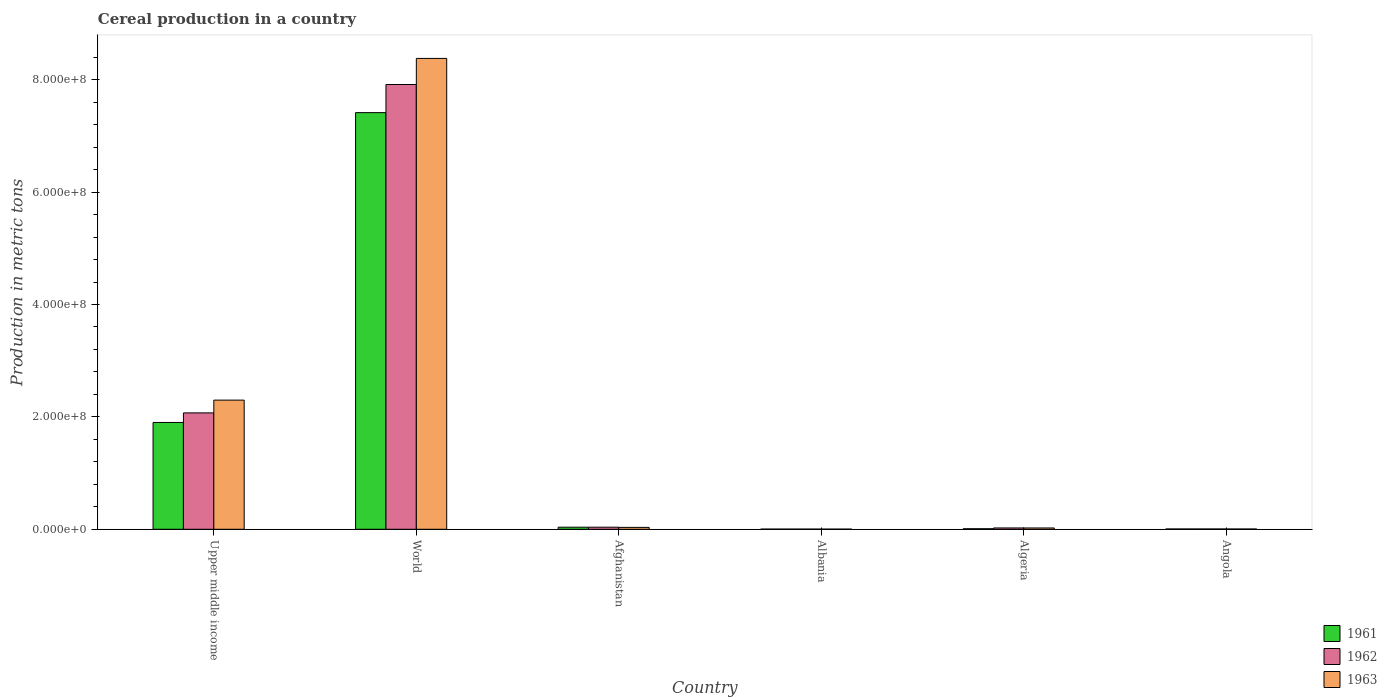Are the number of bars per tick equal to the number of legend labels?
Your answer should be very brief. Yes. Are the number of bars on each tick of the X-axis equal?
Offer a very short reply. Yes. What is the label of the 4th group of bars from the left?
Offer a very short reply. Albania. In how many cases, is the number of bars for a given country not equal to the number of legend labels?
Make the answer very short. 0. What is the total cereal production in 1961 in Algeria?
Keep it short and to the point. 9.38e+05. Across all countries, what is the maximum total cereal production in 1962?
Give a very brief answer. 7.92e+08. Across all countries, what is the minimum total cereal production in 1961?
Your answer should be very brief. 2.94e+05. In which country was the total cereal production in 1963 maximum?
Provide a succinct answer. World. In which country was the total cereal production in 1963 minimum?
Offer a terse response. Albania. What is the total total cereal production in 1962 in the graph?
Your response must be concise. 1.01e+09. What is the difference between the total cereal production in 1961 in Algeria and that in World?
Provide a short and direct response. -7.41e+08. What is the difference between the total cereal production in 1962 in Angola and the total cereal production in 1963 in Albania?
Your answer should be very brief. 2.50e+05. What is the average total cereal production in 1961 per country?
Your answer should be compact. 1.56e+08. What is the difference between the total cereal production of/in 1963 and total cereal production of/in 1962 in Angola?
Offer a very short reply. -2.80e+04. What is the ratio of the total cereal production in 1961 in Albania to that in World?
Ensure brevity in your answer.  0. What is the difference between the highest and the second highest total cereal production in 1962?
Offer a terse response. -2.03e+08. What is the difference between the highest and the lowest total cereal production in 1962?
Make the answer very short. 7.91e+08. What does the 2nd bar from the left in Algeria represents?
Offer a terse response. 1962. What does the 3rd bar from the right in Upper middle income represents?
Provide a short and direct response. 1961. Is it the case that in every country, the sum of the total cereal production in 1962 and total cereal production in 1963 is greater than the total cereal production in 1961?
Make the answer very short. Yes. How many bars are there?
Your answer should be very brief. 18. How many countries are there in the graph?
Your answer should be compact. 6. What is the difference between two consecutive major ticks on the Y-axis?
Offer a very short reply. 2.00e+08. Are the values on the major ticks of Y-axis written in scientific E-notation?
Your answer should be very brief. Yes. Does the graph contain grids?
Your answer should be compact. No. Where does the legend appear in the graph?
Ensure brevity in your answer.  Bottom right. What is the title of the graph?
Your answer should be very brief. Cereal production in a country. Does "1980" appear as one of the legend labels in the graph?
Offer a very short reply. No. What is the label or title of the Y-axis?
Your answer should be compact. Production in metric tons. What is the Production in metric tons in 1961 in Upper middle income?
Ensure brevity in your answer.  1.90e+08. What is the Production in metric tons of 1962 in Upper middle income?
Offer a very short reply. 2.07e+08. What is the Production in metric tons in 1963 in Upper middle income?
Your response must be concise. 2.30e+08. What is the Production in metric tons of 1961 in World?
Ensure brevity in your answer.  7.41e+08. What is the Production in metric tons in 1962 in World?
Your answer should be very brief. 7.92e+08. What is the Production in metric tons of 1963 in World?
Provide a short and direct response. 8.38e+08. What is the Production in metric tons of 1961 in Afghanistan?
Keep it short and to the point. 3.70e+06. What is the Production in metric tons of 1962 in Afghanistan?
Provide a short and direct response. 3.70e+06. What is the Production in metric tons in 1963 in Afghanistan?
Provide a succinct answer. 3.38e+06. What is the Production in metric tons of 1961 in Albania?
Your answer should be very brief. 2.94e+05. What is the Production in metric tons of 1962 in Albania?
Your response must be concise. 3.14e+05. What is the Production in metric tons in 1963 in Albania?
Provide a succinct answer. 2.93e+05. What is the Production in metric tons in 1961 in Algeria?
Keep it short and to the point. 9.38e+05. What is the Production in metric tons of 1962 in Algeria?
Keep it short and to the point. 2.37e+06. What is the Production in metric tons of 1963 in Algeria?
Provide a short and direct response. 2.32e+06. What is the Production in metric tons of 1961 in Angola?
Offer a very short reply. 5.44e+05. What is the Production in metric tons in 1962 in Angola?
Ensure brevity in your answer.  5.43e+05. What is the Production in metric tons of 1963 in Angola?
Keep it short and to the point. 5.15e+05. Across all countries, what is the maximum Production in metric tons of 1961?
Your response must be concise. 7.41e+08. Across all countries, what is the maximum Production in metric tons of 1962?
Provide a short and direct response. 7.92e+08. Across all countries, what is the maximum Production in metric tons of 1963?
Give a very brief answer. 8.38e+08. Across all countries, what is the minimum Production in metric tons of 1961?
Provide a short and direct response. 2.94e+05. Across all countries, what is the minimum Production in metric tons of 1962?
Provide a short and direct response. 3.14e+05. Across all countries, what is the minimum Production in metric tons of 1963?
Offer a very short reply. 2.93e+05. What is the total Production in metric tons of 1961 in the graph?
Ensure brevity in your answer.  9.37e+08. What is the total Production in metric tons of 1962 in the graph?
Give a very brief answer. 1.01e+09. What is the total Production in metric tons of 1963 in the graph?
Provide a short and direct response. 1.07e+09. What is the difference between the Production in metric tons in 1961 in Upper middle income and that in World?
Make the answer very short. -5.51e+08. What is the difference between the Production in metric tons in 1962 in Upper middle income and that in World?
Give a very brief answer. -5.84e+08. What is the difference between the Production in metric tons in 1963 in Upper middle income and that in World?
Provide a succinct answer. -6.08e+08. What is the difference between the Production in metric tons of 1961 in Upper middle income and that in Afghanistan?
Your response must be concise. 1.86e+08. What is the difference between the Production in metric tons in 1962 in Upper middle income and that in Afghanistan?
Keep it short and to the point. 2.03e+08. What is the difference between the Production in metric tons in 1963 in Upper middle income and that in Afghanistan?
Provide a succinct answer. 2.26e+08. What is the difference between the Production in metric tons in 1961 in Upper middle income and that in Albania?
Make the answer very short. 1.90e+08. What is the difference between the Production in metric tons in 1962 in Upper middle income and that in Albania?
Make the answer very short. 2.07e+08. What is the difference between the Production in metric tons in 1963 in Upper middle income and that in Albania?
Make the answer very short. 2.30e+08. What is the difference between the Production in metric tons of 1961 in Upper middle income and that in Algeria?
Provide a succinct answer. 1.89e+08. What is the difference between the Production in metric tons of 1962 in Upper middle income and that in Algeria?
Offer a very short reply. 2.05e+08. What is the difference between the Production in metric tons of 1963 in Upper middle income and that in Algeria?
Ensure brevity in your answer.  2.28e+08. What is the difference between the Production in metric tons in 1961 in Upper middle income and that in Angola?
Your answer should be very brief. 1.90e+08. What is the difference between the Production in metric tons of 1962 in Upper middle income and that in Angola?
Provide a succinct answer. 2.07e+08. What is the difference between the Production in metric tons of 1963 in Upper middle income and that in Angola?
Make the answer very short. 2.29e+08. What is the difference between the Production in metric tons of 1961 in World and that in Afghanistan?
Offer a very short reply. 7.38e+08. What is the difference between the Production in metric tons in 1962 in World and that in Afghanistan?
Provide a succinct answer. 7.88e+08. What is the difference between the Production in metric tons in 1963 in World and that in Afghanistan?
Provide a succinct answer. 8.35e+08. What is the difference between the Production in metric tons in 1961 in World and that in Albania?
Give a very brief answer. 7.41e+08. What is the difference between the Production in metric tons of 1962 in World and that in Albania?
Make the answer very short. 7.91e+08. What is the difference between the Production in metric tons in 1963 in World and that in Albania?
Offer a very short reply. 8.38e+08. What is the difference between the Production in metric tons in 1961 in World and that in Algeria?
Offer a terse response. 7.41e+08. What is the difference between the Production in metric tons of 1962 in World and that in Algeria?
Provide a short and direct response. 7.89e+08. What is the difference between the Production in metric tons in 1963 in World and that in Algeria?
Your answer should be very brief. 8.36e+08. What is the difference between the Production in metric tons of 1961 in World and that in Angola?
Provide a short and direct response. 7.41e+08. What is the difference between the Production in metric tons of 1962 in World and that in Angola?
Your answer should be very brief. 7.91e+08. What is the difference between the Production in metric tons of 1963 in World and that in Angola?
Give a very brief answer. 8.37e+08. What is the difference between the Production in metric tons in 1961 in Afghanistan and that in Albania?
Keep it short and to the point. 3.40e+06. What is the difference between the Production in metric tons in 1962 in Afghanistan and that in Albania?
Ensure brevity in your answer.  3.38e+06. What is the difference between the Production in metric tons in 1963 in Afghanistan and that in Albania?
Your answer should be very brief. 3.08e+06. What is the difference between the Production in metric tons of 1961 in Afghanistan and that in Algeria?
Provide a succinct answer. 2.76e+06. What is the difference between the Production in metric tons in 1962 in Afghanistan and that in Algeria?
Your answer should be compact. 1.33e+06. What is the difference between the Production in metric tons in 1963 in Afghanistan and that in Algeria?
Give a very brief answer. 1.05e+06. What is the difference between the Production in metric tons of 1961 in Afghanistan and that in Angola?
Your answer should be compact. 3.15e+06. What is the difference between the Production in metric tons in 1962 in Afghanistan and that in Angola?
Keep it short and to the point. 3.15e+06. What is the difference between the Production in metric tons of 1963 in Afghanistan and that in Angola?
Provide a succinct answer. 2.86e+06. What is the difference between the Production in metric tons of 1961 in Albania and that in Algeria?
Make the answer very short. -6.44e+05. What is the difference between the Production in metric tons of 1962 in Albania and that in Algeria?
Your answer should be very brief. -2.06e+06. What is the difference between the Production in metric tons of 1963 in Albania and that in Algeria?
Your answer should be compact. -2.03e+06. What is the difference between the Production in metric tons in 1961 in Albania and that in Angola?
Provide a short and direct response. -2.50e+05. What is the difference between the Production in metric tons of 1962 in Albania and that in Angola?
Your answer should be compact. -2.29e+05. What is the difference between the Production in metric tons in 1963 in Albania and that in Angola?
Provide a succinct answer. -2.22e+05. What is the difference between the Production in metric tons in 1961 in Algeria and that in Angola?
Keep it short and to the point. 3.94e+05. What is the difference between the Production in metric tons in 1962 in Algeria and that in Angola?
Ensure brevity in your answer.  1.83e+06. What is the difference between the Production in metric tons in 1963 in Algeria and that in Angola?
Your response must be concise. 1.81e+06. What is the difference between the Production in metric tons of 1961 in Upper middle income and the Production in metric tons of 1962 in World?
Your answer should be compact. -6.01e+08. What is the difference between the Production in metric tons in 1961 in Upper middle income and the Production in metric tons in 1963 in World?
Your answer should be compact. -6.48e+08. What is the difference between the Production in metric tons in 1962 in Upper middle income and the Production in metric tons in 1963 in World?
Provide a short and direct response. -6.31e+08. What is the difference between the Production in metric tons of 1961 in Upper middle income and the Production in metric tons of 1962 in Afghanistan?
Ensure brevity in your answer.  1.86e+08. What is the difference between the Production in metric tons of 1961 in Upper middle income and the Production in metric tons of 1963 in Afghanistan?
Ensure brevity in your answer.  1.87e+08. What is the difference between the Production in metric tons of 1962 in Upper middle income and the Production in metric tons of 1963 in Afghanistan?
Make the answer very short. 2.04e+08. What is the difference between the Production in metric tons of 1961 in Upper middle income and the Production in metric tons of 1962 in Albania?
Make the answer very short. 1.90e+08. What is the difference between the Production in metric tons of 1961 in Upper middle income and the Production in metric tons of 1963 in Albania?
Give a very brief answer. 1.90e+08. What is the difference between the Production in metric tons in 1962 in Upper middle income and the Production in metric tons in 1963 in Albania?
Your response must be concise. 2.07e+08. What is the difference between the Production in metric tons of 1961 in Upper middle income and the Production in metric tons of 1962 in Algeria?
Provide a succinct answer. 1.88e+08. What is the difference between the Production in metric tons of 1961 in Upper middle income and the Production in metric tons of 1963 in Algeria?
Keep it short and to the point. 1.88e+08. What is the difference between the Production in metric tons of 1962 in Upper middle income and the Production in metric tons of 1963 in Algeria?
Ensure brevity in your answer.  2.05e+08. What is the difference between the Production in metric tons of 1961 in Upper middle income and the Production in metric tons of 1962 in Angola?
Ensure brevity in your answer.  1.90e+08. What is the difference between the Production in metric tons in 1961 in Upper middle income and the Production in metric tons in 1963 in Angola?
Ensure brevity in your answer.  1.90e+08. What is the difference between the Production in metric tons in 1962 in Upper middle income and the Production in metric tons in 1963 in Angola?
Your answer should be very brief. 2.07e+08. What is the difference between the Production in metric tons of 1961 in World and the Production in metric tons of 1962 in Afghanistan?
Provide a short and direct response. 7.38e+08. What is the difference between the Production in metric tons in 1961 in World and the Production in metric tons in 1963 in Afghanistan?
Your answer should be compact. 7.38e+08. What is the difference between the Production in metric tons of 1962 in World and the Production in metric tons of 1963 in Afghanistan?
Give a very brief answer. 7.88e+08. What is the difference between the Production in metric tons in 1961 in World and the Production in metric tons in 1962 in Albania?
Provide a succinct answer. 7.41e+08. What is the difference between the Production in metric tons of 1961 in World and the Production in metric tons of 1963 in Albania?
Your answer should be very brief. 7.41e+08. What is the difference between the Production in metric tons of 1962 in World and the Production in metric tons of 1963 in Albania?
Give a very brief answer. 7.91e+08. What is the difference between the Production in metric tons in 1961 in World and the Production in metric tons in 1962 in Algeria?
Ensure brevity in your answer.  7.39e+08. What is the difference between the Production in metric tons in 1961 in World and the Production in metric tons in 1963 in Algeria?
Provide a succinct answer. 7.39e+08. What is the difference between the Production in metric tons of 1962 in World and the Production in metric tons of 1963 in Algeria?
Make the answer very short. 7.89e+08. What is the difference between the Production in metric tons of 1961 in World and the Production in metric tons of 1962 in Angola?
Your answer should be compact. 7.41e+08. What is the difference between the Production in metric tons of 1961 in World and the Production in metric tons of 1963 in Angola?
Provide a succinct answer. 7.41e+08. What is the difference between the Production in metric tons in 1962 in World and the Production in metric tons in 1963 in Angola?
Your answer should be compact. 7.91e+08. What is the difference between the Production in metric tons of 1961 in Afghanistan and the Production in metric tons of 1962 in Albania?
Your response must be concise. 3.38e+06. What is the difference between the Production in metric tons in 1961 in Afghanistan and the Production in metric tons in 1963 in Albania?
Your response must be concise. 3.40e+06. What is the difference between the Production in metric tons in 1962 in Afghanistan and the Production in metric tons in 1963 in Albania?
Your answer should be very brief. 3.40e+06. What is the difference between the Production in metric tons of 1961 in Afghanistan and the Production in metric tons of 1962 in Algeria?
Your answer should be compact. 1.33e+06. What is the difference between the Production in metric tons in 1961 in Afghanistan and the Production in metric tons in 1963 in Algeria?
Your answer should be very brief. 1.37e+06. What is the difference between the Production in metric tons in 1962 in Afghanistan and the Production in metric tons in 1963 in Algeria?
Provide a succinct answer. 1.37e+06. What is the difference between the Production in metric tons in 1961 in Afghanistan and the Production in metric tons in 1962 in Angola?
Keep it short and to the point. 3.15e+06. What is the difference between the Production in metric tons of 1961 in Afghanistan and the Production in metric tons of 1963 in Angola?
Make the answer very short. 3.18e+06. What is the difference between the Production in metric tons of 1962 in Afghanistan and the Production in metric tons of 1963 in Angola?
Keep it short and to the point. 3.18e+06. What is the difference between the Production in metric tons in 1961 in Albania and the Production in metric tons in 1962 in Algeria?
Make the answer very short. -2.08e+06. What is the difference between the Production in metric tons of 1961 in Albania and the Production in metric tons of 1963 in Algeria?
Keep it short and to the point. -2.03e+06. What is the difference between the Production in metric tons in 1962 in Albania and the Production in metric tons in 1963 in Algeria?
Offer a terse response. -2.01e+06. What is the difference between the Production in metric tons of 1961 in Albania and the Production in metric tons of 1962 in Angola?
Ensure brevity in your answer.  -2.49e+05. What is the difference between the Production in metric tons in 1961 in Albania and the Production in metric tons in 1963 in Angola?
Make the answer very short. -2.21e+05. What is the difference between the Production in metric tons in 1962 in Albania and the Production in metric tons in 1963 in Angola?
Provide a succinct answer. -2.01e+05. What is the difference between the Production in metric tons of 1961 in Algeria and the Production in metric tons of 1962 in Angola?
Offer a terse response. 3.95e+05. What is the difference between the Production in metric tons of 1961 in Algeria and the Production in metric tons of 1963 in Angola?
Give a very brief answer. 4.23e+05. What is the difference between the Production in metric tons in 1962 in Algeria and the Production in metric tons in 1963 in Angola?
Offer a very short reply. 1.85e+06. What is the average Production in metric tons in 1961 per country?
Offer a terse response. 1.56e+08. What is the average Production in metric tons in 1962 per country?
Ensure brevity in your answer.  1.68e+08. What is the average Production in metric tons of 1963 per country?
Your answer should be compact. 1.79e+08. What is the difference between the Production in metric tons of 1961 and Production in metric tons of 1962 in Upper middle income?
Provide a short and direct response. -1.70e+07. What is the difference between the Production in metric tons in 1961 and Production in metric tons in 1963 in Upper middle income?
Offer a terse response. -3.98e+07. What is the difference between the Production in metric tons of 1962 and Production in metric tons of 1963 in Upper middle income?
Provide a short and direct response. -2.27e+07. What is the difference between the Production in metric tons in 1961 and Production in metric tons in 1962 in World?
Your answer should be compact. -5.00e+07. What is the difference between the Production in metric tons of 1961 and Production in metric tons of 1963 in World?
Give a very brief answer. -9.65e+07. What is the difference between the Production in metric tons in 1962 and Production in metric tons in 1963 in World?
Ensure brevity in your answer.  -4.64e+07. What is the difference between the Production in metric tons in 1961 and Production in metric tons in 1962 in Afghanistan?
Your answer should be compact. -1000. What is the difference between the Production in metric tons of 1961 and Production in metric tons of 1963 in Afghanistan?
Offer a very short reply. 3.17e+05. What is the difference between the Production in metric tons in 1962 and Production in metric tons in 1963 in Afghanistan?
Your answer should be compact. 3.18e+05. What is the difference between the Production in metric tons in 1961 and Production in metric tons in 1962 in Albania?
Make the answer very short. -1.96e+04. What is the difference between the Production in metric tons in 1961 and Production in metric tons in 1963 in Albania?
Make the answer very short. 483. What is the difference between the Production in metric tons of 1962 and Production in metric tons of 1963 in Albania?
Give a very brief answer. 2.01e+04. What is the difference between the Production in metric tons of 1961 and Production in metric tons of 1962 in Algeria?
Offer a terse response. -1.43e+06. What is the difference between the Production in metric tons in 1961 and Production in metric tons in 1963 in Algeria?
Your answer should be compact. -1.39e+06. What is the difference between the Production in metric tons of 1962 and Production in metric tons of 1963 in Algeria?
Ensure brevity in your answer.  4.56e+04. What is the difference between the Production in metric tons of 1961 and Production in metric tons of 1962 in Angola?
Keep it short and to the point. 1000. What is the difference between the Production in metric tons in 1961 and Production in metric tons in 1963 in Angola?
Ensure brevity in your answer.  2.90e+04. What is the difference between the Production in metric tons of 1962 and Production in metric tons of 1963 in Angola?
Provide a succinct answer. 2.80e+04. What is the ratio of the Production in metric tons of 1961 in Upper middle income to that in World?
Offer a very short reply. 0.26. What is the ratio of the Production in metric tons in 1962 in Upper middle income to that in World?
Keep it short and to the point. 0.26. What is the ratio of the Production in metric tons in 1963 in Upper middle income to that in World?
Your answer should be compact. 0.27. What is the ratio of the Production in metric tons of 1961 in Upper middle income to that in Afghanistan?
Ensure brevity in your answer.  51.45. What is the ratio of the Production in metric tons in 1962 in Upper middle income to that in Afghanistan?
Provide a short and direct response. 56.04. What is the ratio of the Production in metric tons of 1963 in Upper middle income to that in Afghanistan?
Provide a succinct answer. 68.04. What is the ratio of the Production in metric tons of 1961 in Upper middle income to that in Albania?
Your answer should be compact. 646.73. What is the ratio of the Production in metric tons of 1962 in Upper middle income to that in Albania?
Provide a succinct answer. 660.64. What is the ratio of the Production in metric tons in 1963 in Upper middle income to that in Albania?
Your answer should be very brief. 783.25. What is the ratio of the Production in metric tons of 1961 in Upper middle income to that in Algeria?
Keep it short and to the point. 202.75. What is the ratio of the Production in metric tons of 1962 in Upper middle income to that in Algeria?
Your answer should be compact. 87.4. What is the ratio of the Production in metric tons in 1963 in Upper middle income to that in Algeria?
Ensure brevity in your answer.  98.89. What is the ratio of the Production in metric tons in 1961 in Upper middle income to that in Angola?
Provide a succinct answer. 349.44. What is the ratio of the Production in metric tons in 1962 in Upper middle income to that in Angola?
Provide a short and direct response. 381.43. What is the ratio of the Production in metric tons of 1963 in Upper middle income to that in Angola?
Provide a short and direct response. 446.3. What is the ratio of the Production in metric tons of 1961 in World to that in Afghanistan?
Provide a succinct answer. 200.67. What is the ratio of the Production in metric tons of 1962 in World to that in Afghanistan?
Provide a succinct answer. 214.15. What is the ratio of the Production in metric tons of 1963 in World to that in Afghanistan?
Provide a short and direct response. 248.06. What is the ratio of the Production in metric tons in 1961 in World to that in Albania?
Offer a very short reply. 2522.55. What is the ratio of the Production in metric tons in 1962 in World to that in Albania?
Offer a very short reply. 2524.68. What is the ratio of the Production in metric tons in 1963 in World to that in Albania?
Your response must be concise. 2855.5. What is the ratio of the Production in metric tons in 1961 in World to that in Algeria?
Offer a very short reply. 790.81. What is the ratio of the Production in metric tons in 1962 in World to that in Algeria?
Your answer should be compact. 334. What is the ratio of the Production in metric tons in 1963 in World to that in Algeria?
Offer a terse response. 360.53. What is the ratio of the Production in metric tons of 1961 in World to that in Angola?
Make the answer very short. 1362.97. What is the ratio of the Production in metric tons in 1962 in World to that in Angola?
Provide a succinct answer. 1457.65. What is the ratio of the Production in metric tons in 1963 in World to that in Angola?
Offer a terse response. 1627.08. What is the ratio of the Production in metric tons of 1961 in Afghanistan to that in Albania?
Ensure brevity in your answer.  12.57. What is the ratio of the Production in metric tons in 1962 in Afghanistan to that in Albania?
Provide a succinct answer. 11.79. What is the ratio of the Production in metric tons of 1963 in Afghanistan to that in Albania?
Provide a succinct answer. 11.51. What is the ratio of the Production in metric tons in 1961 in Afghanistan to that in Algeria?
Provide a short and direct response. 3.94. What is the ratio of the Production in metric tons in 1962 in Afghanistan to that in Algeria?
Your response must be concise. 1.56. What is the ratio of the Production in metric tons of 1963 in Afghanistan to that in Algeria?
Your answer should be compact. 1.45. What is the ratio of the Production in metric tons in 1961 in Afghanistan to that in Angola?
Your answer should be compact. 6.79. What is the ratio of the Production in metric tons of 1962 in Afghanistan to that in Angola?
Your response must be concise. 6.81. What is the ratio of the Production in metric tons in 1963 in Afghanistan to that in Angola?
Provide a short and direct response. 6.56. What is the ratio of the Production in metric tons of 1961 in Albania to that in Algeria?
Your answer should be very brief. 0.31. What is the ratio of the Production in metric tons in 1962 in Albania to that in Algeria?
Provide a short and direct response. 0.13. What is the ratio of the Production in metric tons of 1963 in Albania to that in Algeria?
Your answer should be compact. 0.13. What is the ratio of the Production in metric tons of 1961 in Albania to that in Angola?
Offer a very short reply. 0.54. What is the ratio of the Production in metric tons in 1962 in Albania to that in Angola?
Make the answer very short. 0.58. What is the ratio of the Production in metric tons of 1963 in Albania to that in Angola?
Give a very brief answer. 0.57. What is the ratio of the Production in metric tons in 1961 in Algeria to that in Angola?
Provide a succinct answer. 1.72. What is the ratio of the Production in metric tons of 1962 in Algeria to that in Angola?
Give a very brief answer. 4.36. What is the ratio of the Production in metric tons of 1963 in Algeria to that in Angola?
Your answer should be compact. 4.51. What is the difference between the highest and the second highest Production in metric tons of 1961?
Offer a terse response. 5.51e+08. What is the difference between the highest and the second highest Production in metric tons of 1962?
Offer a terse response. 5.84e+08. What is the difference between the highest and the second highest Production in metric tons of 1963?
Offer a terse response. 6.08e+08. What is the difference between the highest and the lowest Production in metric tons in 1961?
Provide a succinct answer. 7.41e+08. What is the difference between the highest and the lowest Production in metric tons in 1962?
Your answer should be very brief. 7.91e+08. What is the difference between the highest and the lowest Production in metric tons in 1963?
Your response must be concise. 8.38e+08. 